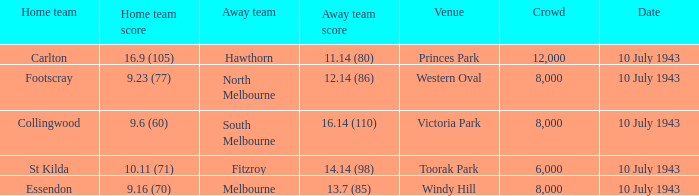When the Home team of carlton played, what was their score? 16.9 (105). 